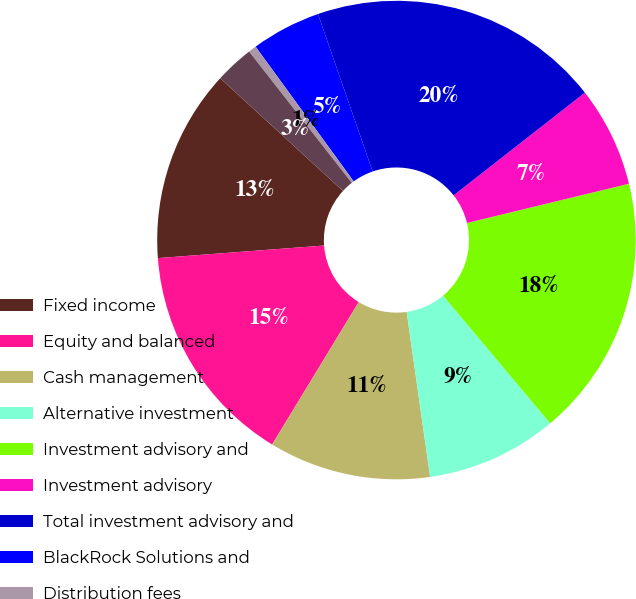Convert chart. <chart><loc_0><loc_0><loc_500><loc_500><pie_chart><fcel>Fixed income<fcel>Equity and balanced<fcel>Cash management<fcel>Alternative investment<fcel>Investment advisory and<fcel>Investment advisory<fcel>Total investment advisory and<fcel>BlackRock Solutions and<fcel>Distribution fees<fcel>Other revenue<nl><fcel>13.02%<fcel>15.1%<fcel>10.94%<fcel>8.86%<fcel>17.67%<fcel>6.78%<fcel>19.75%<fcel>4.7%<fcel>0.54%<fcel>2.62%<nl></chart> 